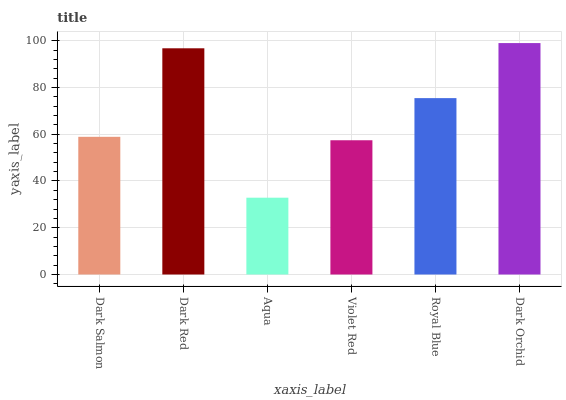Is Aqua the minimum?
Answer yes or no. Yes. Is Dark Orchid the maximum?
Answer yes or no. Yes. Is Dark Red the minimum?
Answer yes or no. No. Is Dark Red the maximum?
Answer yes or no. No. Is Dark Red greater than Dark Salmon?
Answer yes or no. Yes. Is Dark Salmon less than Dark Red?
Answer yes or no. Yes. Is Dark Salmon greater than Dark Red?
Answer yes or no. No. Is Dark Red less than Dark Salmon?
Answer yes or no. No. Is Royal Blue the high median?
Answer yes or no. Yes. Is Dark Salmon the low median?
Answer yes or no. Yes. Is Aqua the high median?
Answer yes or no. No. Is Aqua the low median?
Answer yes or no. No. 